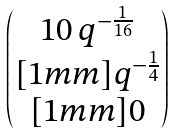Convert formula to latex. <formula><loc_0><loc_0><loc_500><loc_500>\begin{pmatrix} 1 0 \, q ^ { - \frac { 1 } { 1 6 } } \\ [ 1 m m ] q ^ { - \frac { 1 } { 4 } } \\ [ 1 m m ] 0 \end{pmatrix}</formula> 